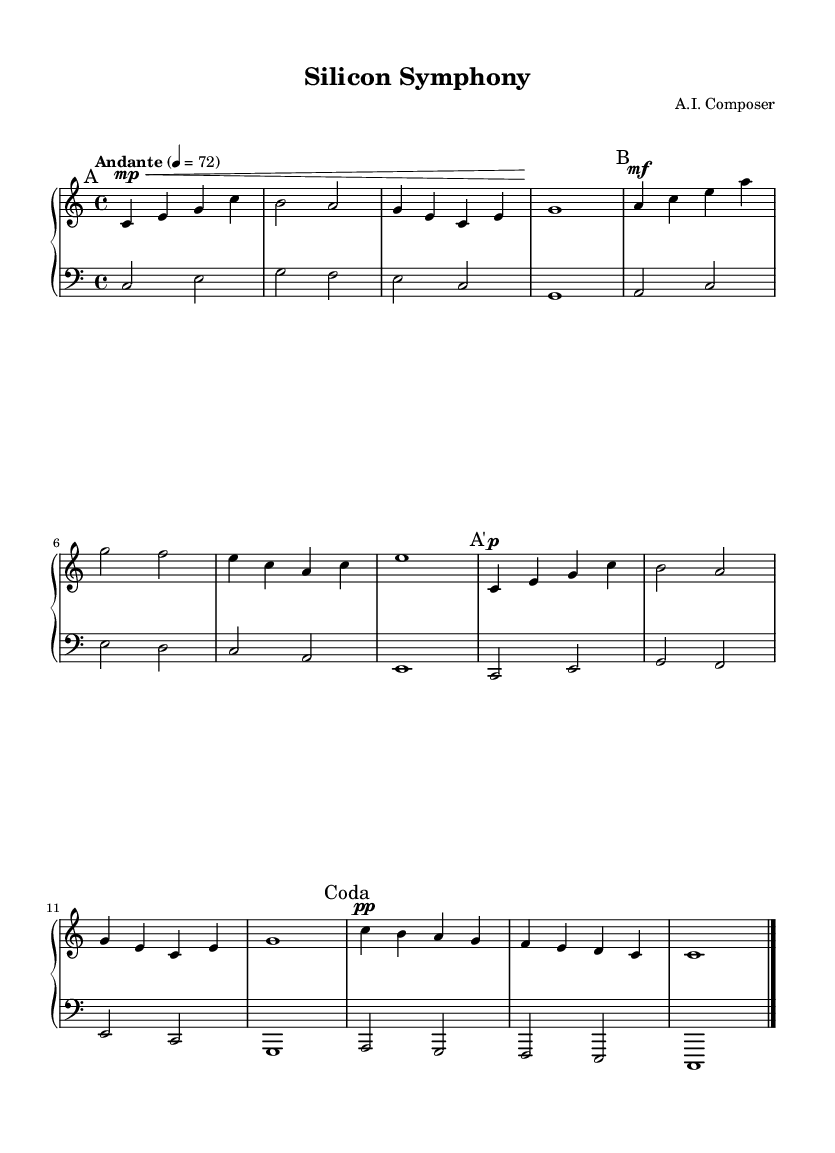What is the key signature of this music? The key signature is indicated at the beginning of the sheet music, showing that it is in C major, which has no sharps or flats.
Answer: C major What is the time signature of this piece? The time signature is shown at the beginning of the music, indicating that it is in 4/4 time, meaning there are four beats per measure.
Answer: 4/4 What is the tempo marking for this composition? The tempo marking at the beginning of the piece specifies "Andante," indicating a moderately slow tempo. The metronome marking of 4 equals 72 further clarifies this speed.
Answer: Andante How many sections does the composition have? The music is divided into distinct sections as marked: A, B, A', and Coda. Counting these markers shows that there are four sections in total.
Answer: 4 Which dynamic marking appears in section Coda? The Coda section has a dynamic marking of "pp," which means "pianissimo," indicating that this section should be played very softly.
Answer: pp What is the last note of the left hand in the Coda section? At the end of the left hand in the Coda section, the last note is indicated as a whole note, which is a C. This can be identified visually from the note's position on the staff.
Answer: C In what context could this composition be used? Given that this is a minimalist piano composition, it is suitable for soundtracks in documentaries, particularly those focused on influential tech innovators, as it provides a reflective and contemplative atmosphere.
Answer: Documentaries 